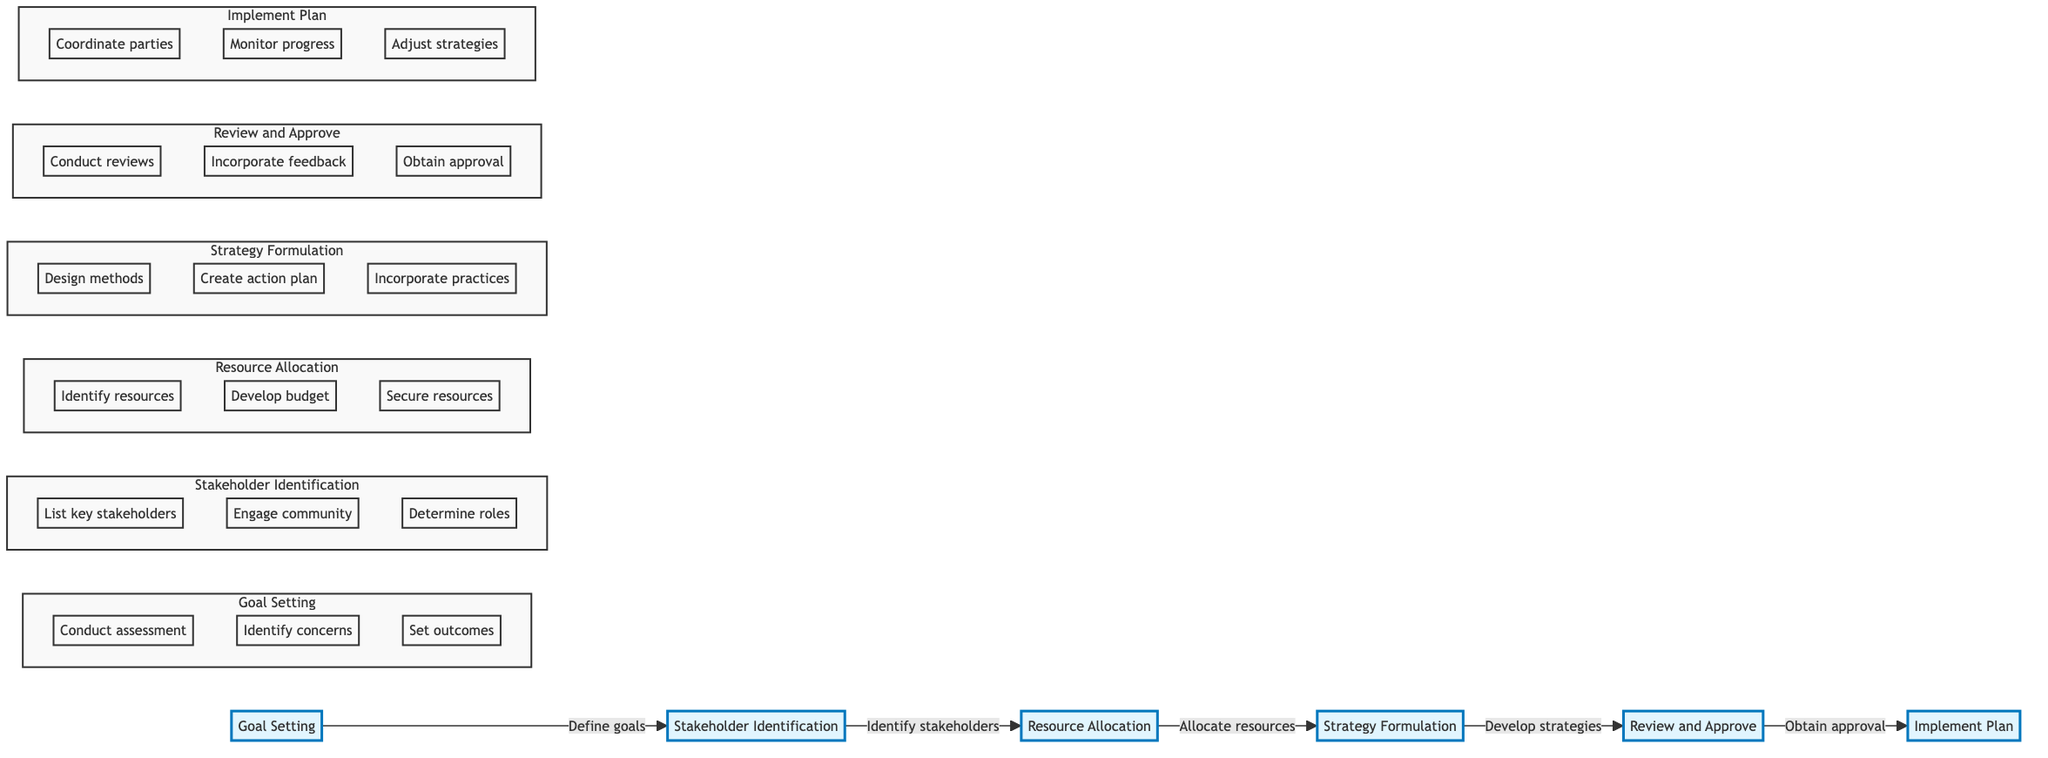What is the first step in the intervention plan development? The diagram indicates that the first step is "Goal Setting," as indicated by the leftmost node in the flowchart.
Answer: Goal Setting How many total steps are there in the intervention plan development? The flowchart presents a sequence of six distinct steps or nodes: Goal Setting, Stakeholder Identification, Resource Allocation, Strategy Formulation, Review and Approve, and Implement Plan. Thus, the total step count is six.
Answer: 6 What are the tasks associated with Resource Allocation? Upon examining the Resource Allocation node, the associated tasks identified are to "Identify available resources," "Develop a budget plan," and "Secure additional resources if needed." These tasks clarify what needs to be accomplished at this step.
Answer: Identify available resources, Develop a budget plan, Secure additional resources What proceeds after Step 3, Resource Allocation? Following the flow of the diagram, the step that comes immediately after Resource Allocation is Strategy Formulation, as the arrows indicate the sequence from one step to the next.
Answer: Strategy Formulation What type of stakeholders are identified in Stakeholder Identification? The Stakeholder Identification tasks include listing "key stakeholders (clients, family, healthcare providers)," meaning these are the types of stakeholders relevant to the intervention.
Answer: Clients, family, healthcare providers What is the final step in the intervention plan development? The last node in the flowchart represents the final step, which is Implement Plan. This can be determined by following the flow of the diagram from the first node to the last.
Answer: Implement Plan What is the purpose of the Review and Approve step? The Review and Approve node specifies the tasks of conducting thorough review meetings, incorporating feedback from stakeholders, and obtaining formal approval. Therefore, its purpose is to ensure the plan is verified and accepted before implementation.
Answer: To ensure the plan is verified and accepted Which step involves designing evidence-based intervention methods? The Strategy Formulation step explicitly states the task of designing "evidence-based intervention methods," indicating that this is the stage where such strategies are developed.
Answer: Strategy Formulation What are the primary tasks in the Implement Plan phase? The tasks listed under the Implement Plan node include coordinating with all involved parties, monitoring progress closely, and adjusting strategies as necessary, highlighting the actions taken to enact the plan.
Answer: Coordinate with all involved parties, Monitor progress closely, Adjust strategies as necessary 